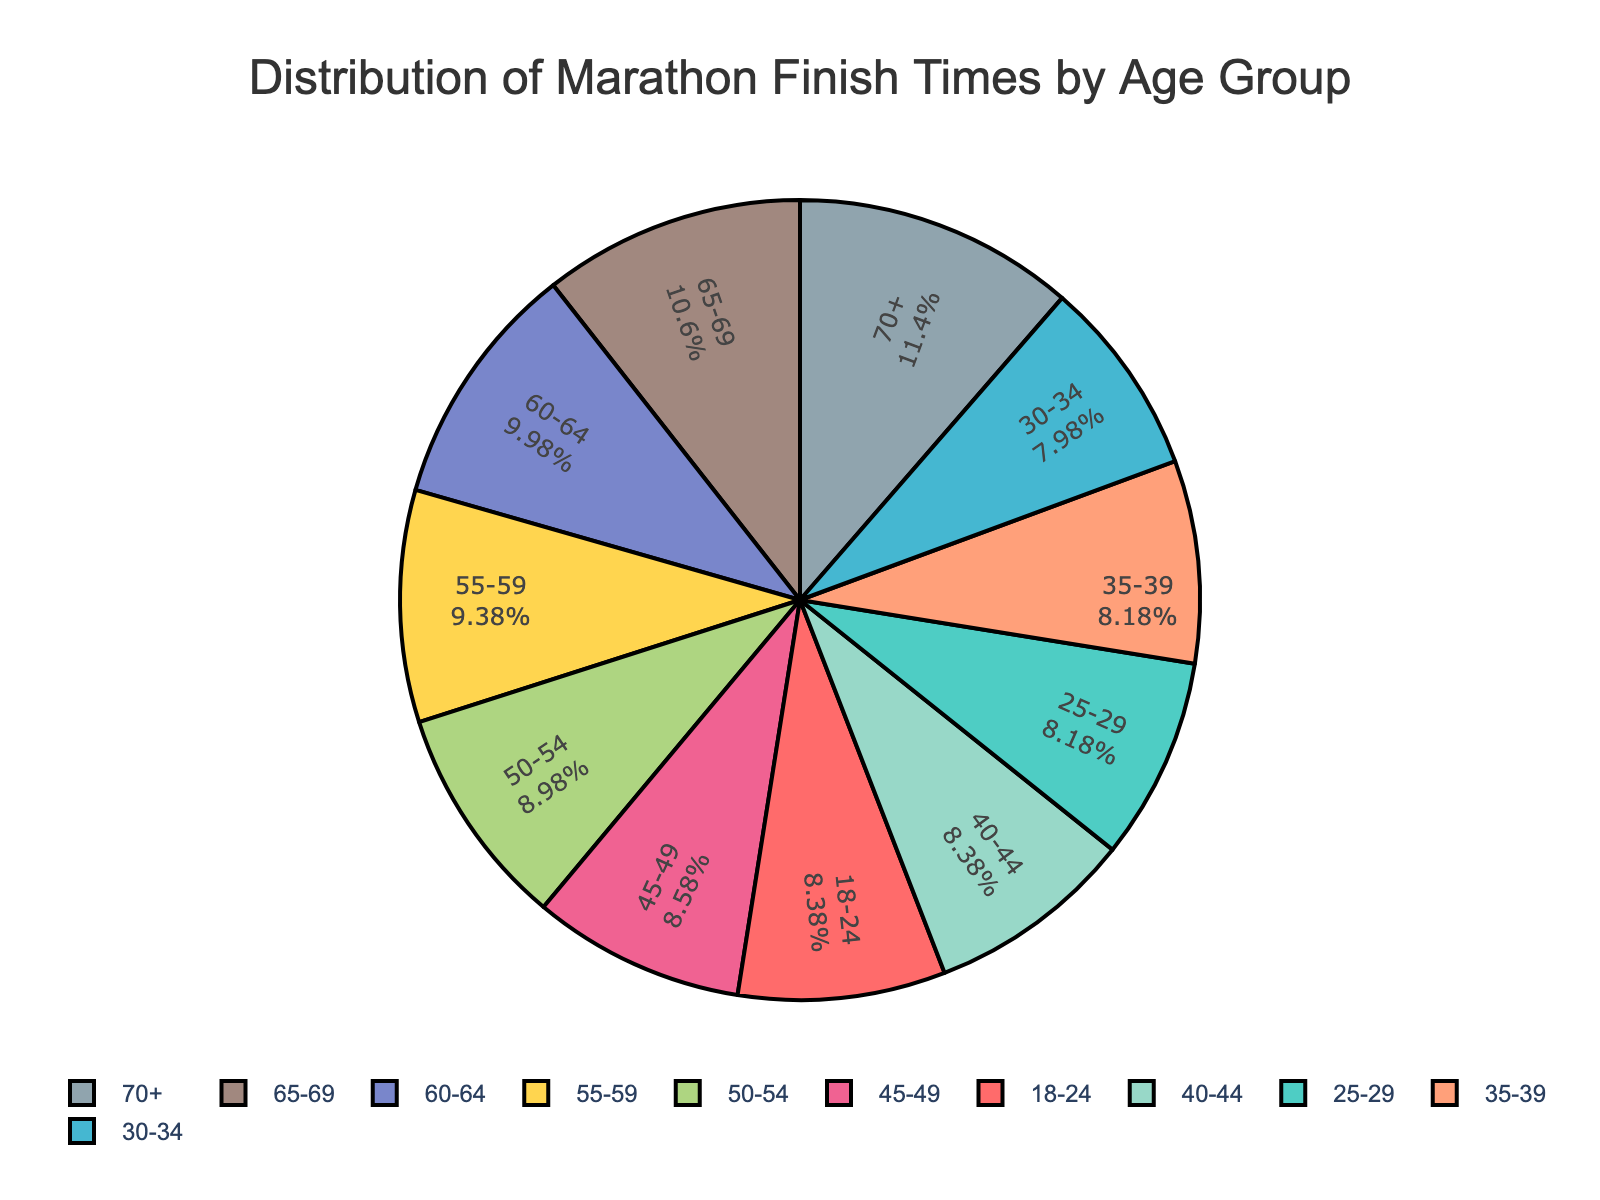What age group has the highest average finish time in the marathon? The age group with the highest average finish time is the segment with the highest value on the pie chart. By comparing the values, it's clear that age group 70+ has the highest average finish time.
Answer: Age group 70+ Which age group has the lowest average finish time in the marathon? The age group with the lowest average finish time is the segment with the lowest value on the pie chart. By comparing the values, it's clear that age group 30-34 has the lowest average finish time.
Answer: Age group 30-34 What is the difference in average finish time between the youngest age group (18-24) and the oldest age group (70+)? The average finish time for the 18-24 age group is 4.2 hours, and for the 70+ age group, it is 5.7 hours. Subtracting these values gives the difference: 5.7 - 4.2 = 1.5 hours.
Answer: 1.5 hours How many age groups have an average finish time of 4.2 hours? From the pie chart, both the 18-24 and 40-44 age groups have an average finish time of 4.2 hours. Counting these, we get two age groups.
Answer: Two age groups Is the average finish time for the 50-54 age group greater than or less than that for the 35-39 age group? The average finish time for the 50-54 age group is 4.5 hours. For the 35-39 age group, it is 4.1 hours. Since 4.5 is greater than 4.1, the average finish time for the 50-54 age group is greater.
Answer: Greater What percentage of the age groups have an average finish time of 5 hours or more? There are 11 age groups in total. The age groups with an average finish time of 5 hours or more are 60-64, 65-69, and 70+. There are 3 age groups in this category. Calculating the percentage: (3/11) * 100 = 27.27%.
Answer: 27.27% Which age groups have a higher average finish time than the 25-29 age group? The 25-29 age group's average finish time is 4.1 hours. Age groups with higher average finish times include 45-49 (4.3), 50-54 (4.5), 55-59 (4.7), 60-64 (5.0), 65-69 (5.3), and 70+ (5.7).
Answer: 45-49, 50-54, 55-59, 60-64, 65-69, 70+ If you combine the average finish times of the 30-34 and 35-39 age groups, what is the sum? The average finish time for the 30-34 age group is 4.0 hours, and for the 35-39 age group, it is 4.1 hours. Summing these values gives: 4.0 + 4.1 = 8.1 hours.
Answer: 8.1 hours Which age group is represented by the light green segment in the pie chart? Since the question refers to visual attributes, find the light green segment on the chart. By matching the colors, the light green segment represents the 25-29 age group.
Answer: 25-29 What is the combined average finish time for the 45-49 and 50-54 age groups, and what does this indicate about runners in their late 40s and early 50s? The average finish time for the 45-49 age group is 4.3 hours, and for the 50-54 age group, it is 4.5 hours. Summing these values: 4.3 + 4.5 = 8.8 hours. This indicates that runners in their late 40s and early 50s tend to have average finish times close to 4.4 hours on average.
Answer: 8.8 hours 